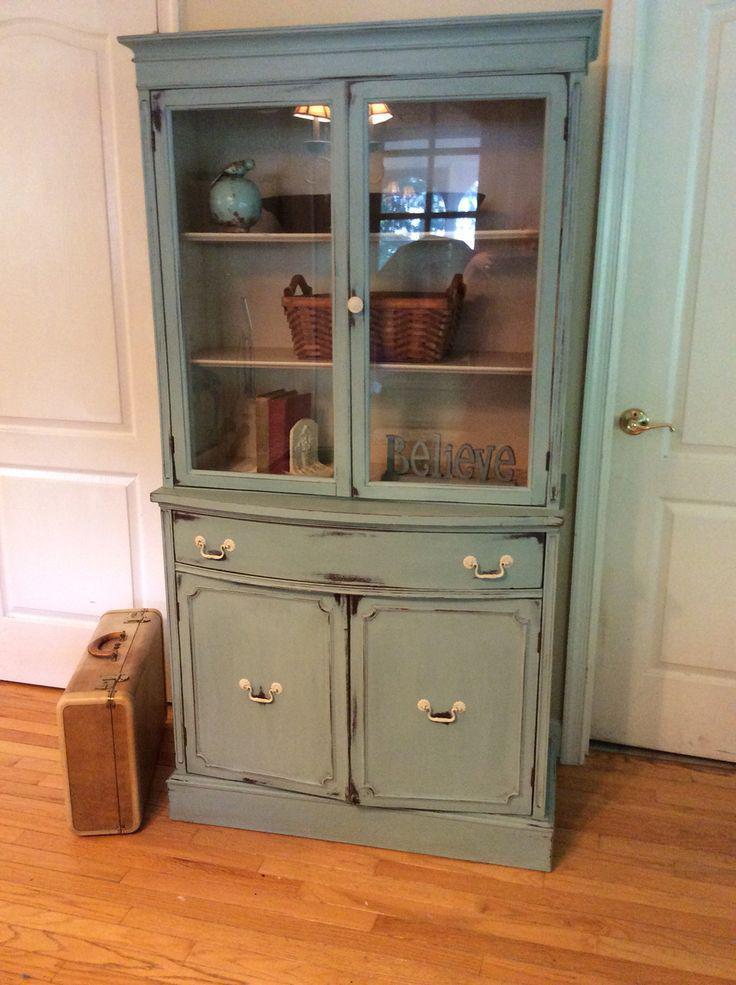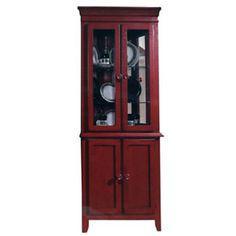The first image is the image on the left, the second image is the image on the right. Analyze the images presented: Is the assertion "The cabinet in the image on the right is bare." valid? Answer yes or no. No. The first image is the image on the left, the second image is the image on the right. Given the left and right images, does the statement "There is no less than one hutch that is completely empty" hold true? Answer yes or no. No. 